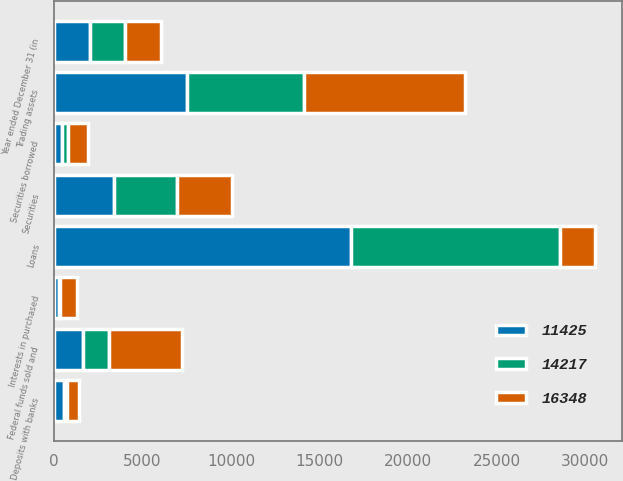Convert chart. <chart><loc_0><loc_0><loc_500><loc_500><stacked_bar_chart><ecel><fcel>Year ended December 31 (in<fcel>Loans<fcel>Securities<fcel>Trading assets<fcel>Federal funds sold and<fcel>Securities borrowed<fcel>Deposits with banks<fcel>Interests in purchased<nl><fcel>16348<fcel>2005<fcel>2003<fcel>3129<fcel>9117<fcel>4125<fcel>1154<fcel>680<fcel>933<nl><fcel>11425<fcel>2004<fcel>16771<fcel>3377<fcel>7527<fcel>1627<fcel>463<fcel>539<fcel>291<nl><fcel>14217<fcel>2003<fcel>11812<fcel>3542<fcel>6592<fcel>1497<fcel>323<fcel>214<fcel>64<nl></chart> 